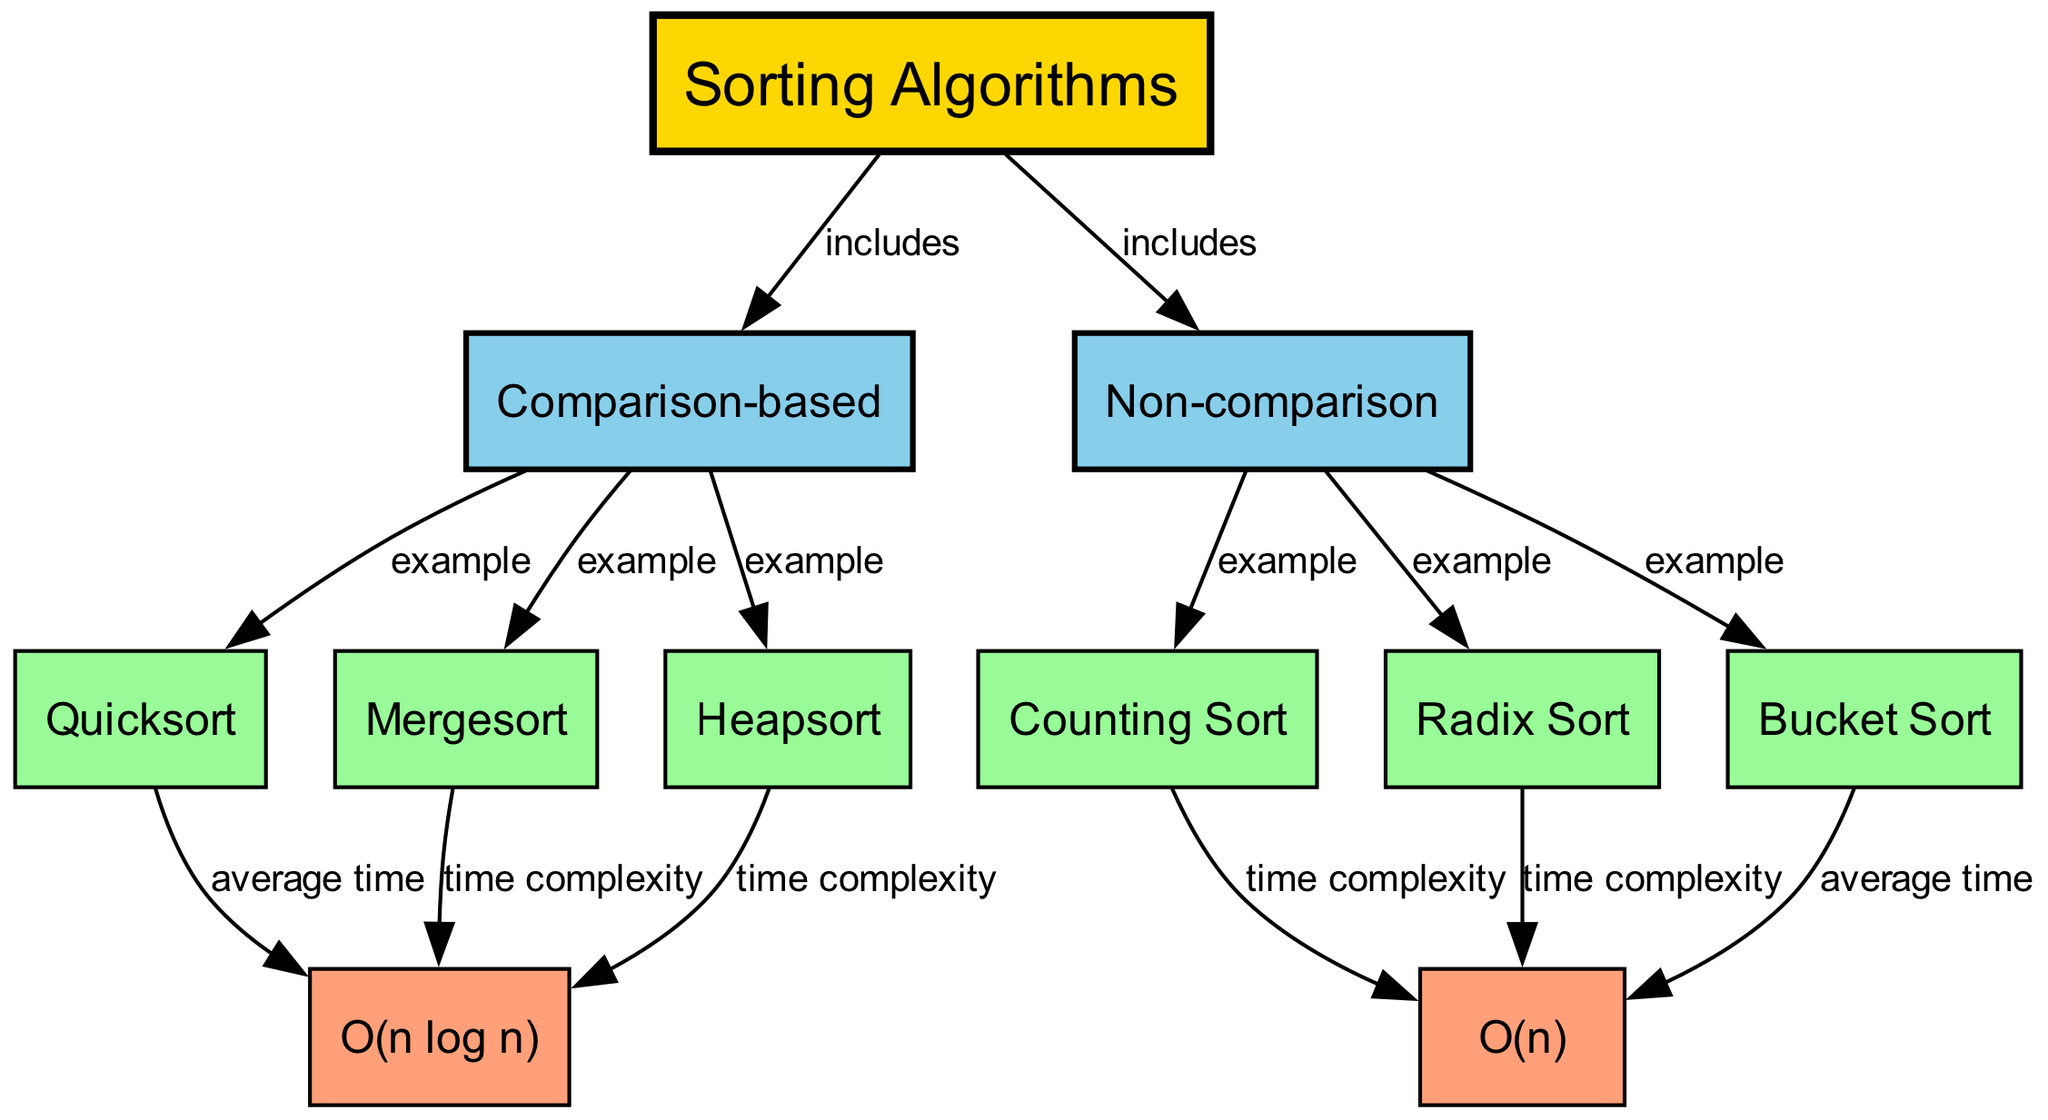What are the main categories of sorting algorithms shown in the diagram? The diagram includes two main categories under "Sorting Algorithms": "Comparison-based" and "Non-comparison".
Answer: Comparison-based, Non-comparison How many examples of comparison-based sorting algorithms are listed? The diagram provides three examples of comparison-based algorithms: Quicksort, Mergesort, and Heapsort. By counting these nodes, we establish that there are three examples.
Answer: 3 Which sorting algorithm has an average time complexity represented as O(n log n)? Quicksort is the algorithm indicated in the diagram with the label "average time" pointing to O(n log n).
Answer: Quicksort What time complexity is associated with counting sort? The time complexity referenced for Counting Sort in the diagram is O(n), indicating it operates in linear time.
Answer: O(n) Which node includes both Quicksort and Mergesort as examples? The diagram shows that both Quicksort and Mergesort are included under the parent node "Comparison-based," which categorizes these algorithms.
Answer: Comparison-based How many total edges are present in the diagram? By analyzing the connections between nodes in the diagram, we find there are a total of 12 edges linking various relationships among the algorithms and their complexities.
Answer: 12 Which type of sorting algorithms includes bucket sort? From the diagram, we see that Bucket Sort is included under "Non-comparison" sorting algorithms, indicating its classification.
Answer: Non-comparison What type of algorithm is represented by Radix Sort? The diagram classifies Radix Sort as a "Non-comparison" sorting algorithm, indicating its operational basis.
Answer: Non-comparison What average time complexity is assigned to bucket sort? The diagram states that the average time complexity of Bucket Sort is O(n), reflecting its efficiency under certain conditions.
Answer: O(n) 